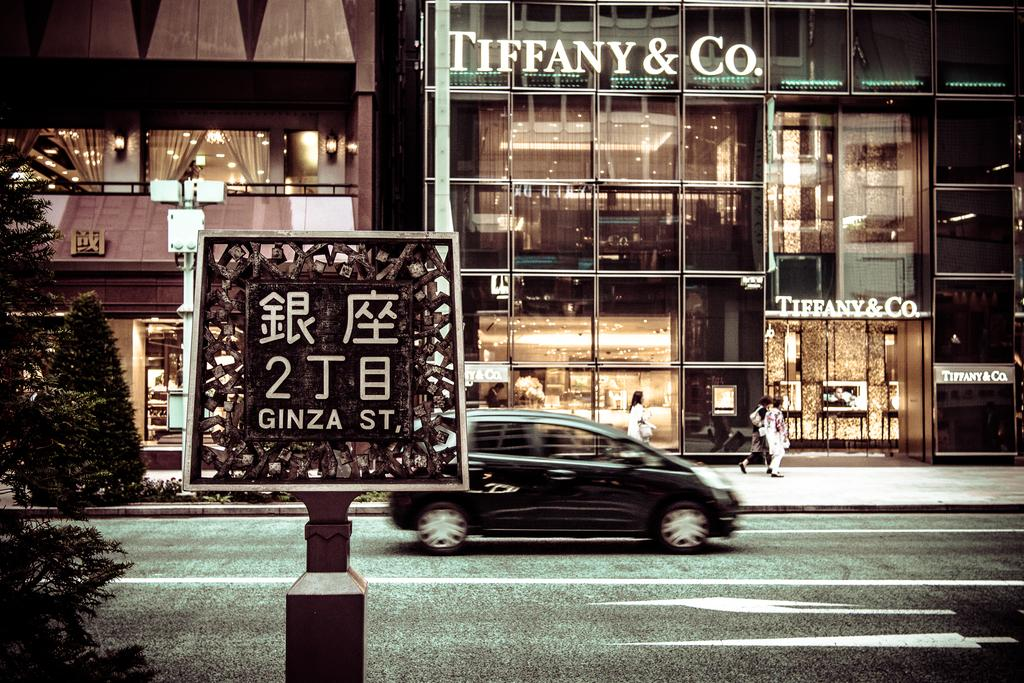What is the main subject of the image? The main subject of the image is a car on the road. What else can be seen in the image besides the car? There is a sign board, trees, buildings, lights, and people visible in the image. What might the sign board be indicating? The specific message on the sign board is not visible, but it could be providing information or directions. What type of structures are present in the image? Buildings are present in the image. What type of stem can be seen growing from the car in the image? There is no stem growing from the car in the image. Is there a door visible on the car in the image? The image does not show a door on the car, as it is focused on the car's front. Can you see a bear walking on the road in the image? There is no bear present in the image; it features a car on the road, a sign board, trees, buildings, lights, and people. 